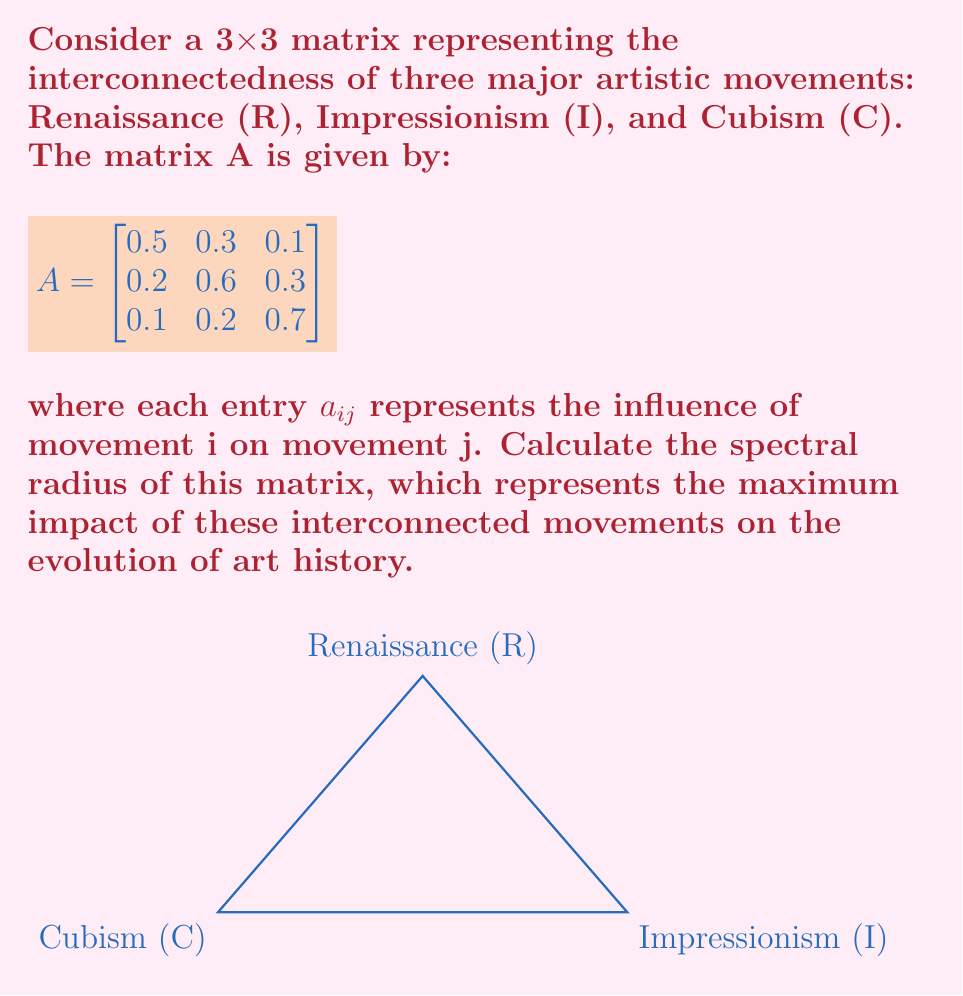Could you help me with this problem? To calculate the spectral radius of matrix A, we need to follow these steps:

1) First, we need to find the characteristic polynomial of A:
   $$det(A - \lambda I) = 0$$

2) Expand the determinant:
   $$\begin{vmatrix}
   0.5-\lambda & 0.3 & 0.1 \\
   0.2 & 0.6-\lambda & 0.3 \\
   0.1 & 0.2 & 0.7-\lambda
   \end{vmatrix} = 0$$

3) Solve the characteristic equation:
   $$(0.5-\lambda)(0.6-\lambda)(0.7-\lambda) - 0.3\cdot0.3\cdot0.1 - 0.1\cdot0.2\cdot0.2 \\
   - (0.5-\lambda)\cdot0.3\cdot0.2 - (0.6-\lambda)\cdot0.1\cdot0.1 - (0.7-\lambda)\cdot0.3\cdot0.2 = 0$$

4) Simplify:
   $$-\lambda^3 + 1.8\lambda^2 - 0.89\lambda + 0.109 = 0$$

5) The roots of this equation are the eigenvalues. Using a numerical method or calculator, we find:
   $$\lambda_1 \approx 0.9397, \lambda_2 \approx 0.4985, \lambda_3 \approx 0.3618$$

6) The spectral radius is the largest absolute value among the eigenvalues:
   $$\rho(A) = \max(|\lambda_1|, |\lambda_2|, |\lambda_3|) = |\lambda_1| \approx 0.9397$$
Answer: $\rho(A) \approx 0.9397$ 